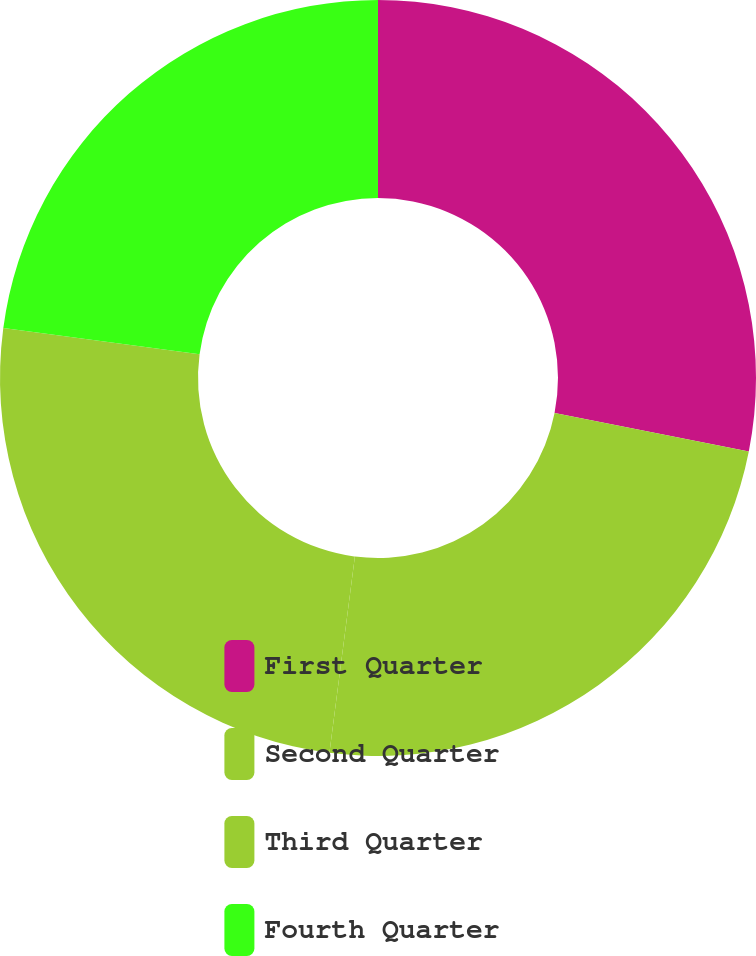<chart> <loc_0><loc_0><loc_500><loc_500><pie_chart><fcel>First Quarter<fcel>Second Quarter<fcel>Third Quarter<fcel>Fourth Quarter<nl><fcel>28.11%<fcel>23.94%<fcel>25.06%<fcel>22.89%<nl></chart> 